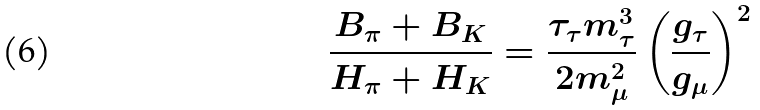<formula> <loc_0><loc_0><loc_500><loc_500>\frac { B _ { \pi } + B _ { K } } { H _ { \pi } + H _ { K } } = \frac { \tau _ { \tau } m _ { \tau } ^ { 3 } } { 2 m _ { \mu } ^ { 2 } } \left ( \frac { g _ { \tau } } { g _ { \mu } } \right ) ^ { 2 }</formula> 